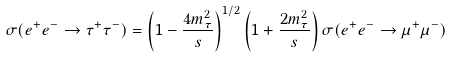Convert formula to latex. <formula><loc_0><loc_0><loc_500><loc_500>\sigma ( e ^ { + } e ^ { - } \to \tau ^ { + } \tau ^ { - } ) = \left ( 1 - \frac { 4 m _ { \tau } ^ { 2 } } { s } \right ) ^ { 1 / 2 } \left ( 1 + \frac { 2 m _ { \tau } ^ { 2 } } { s } \right ) \sigma ( e ^ { + } e ^ { - } \to \mu ^ { + } \mu ^ { - } )</formula> 